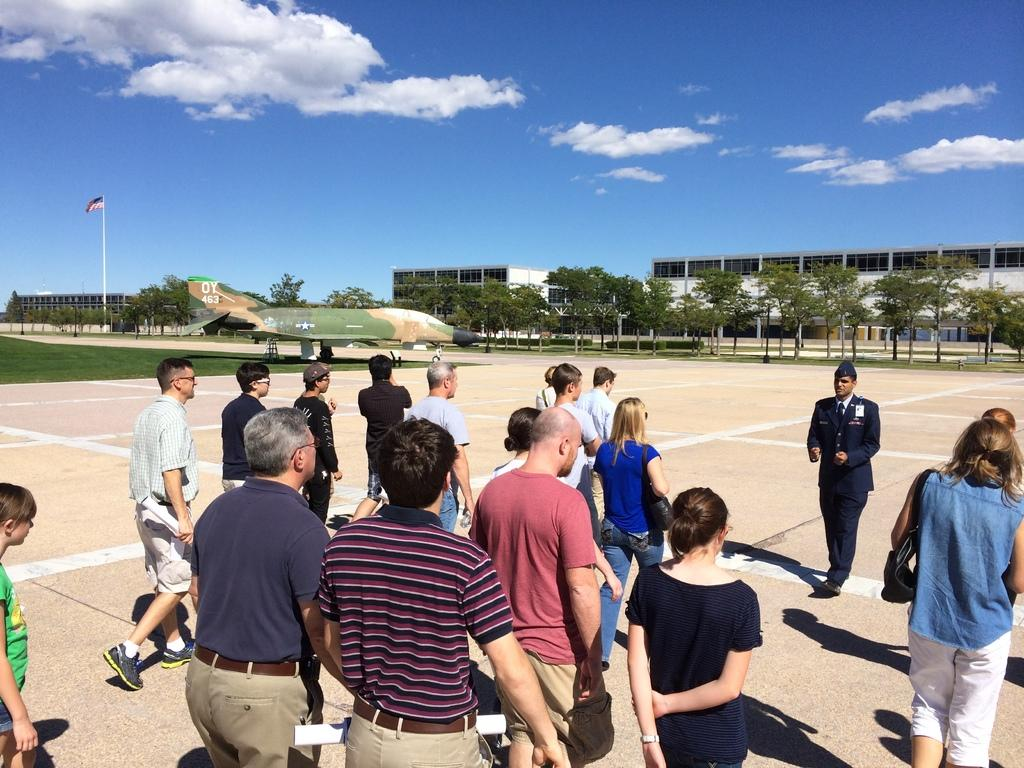Who or what can be seen in the image? There are people in the image. What else is present in the image besides the people? There is an aeroplane in the image. What can be seen in the background of the image? There are buildings and trees in the background of the image. Where is the flag located in the image? The flag is on the left side of the image. What is visible at the top of the image? The sky is visible at the top of the image. What type of rod is being used to hold the calendar in the image? There is no calendar present in the image, so it is not possible to determine if a rod is being used to hold it. 